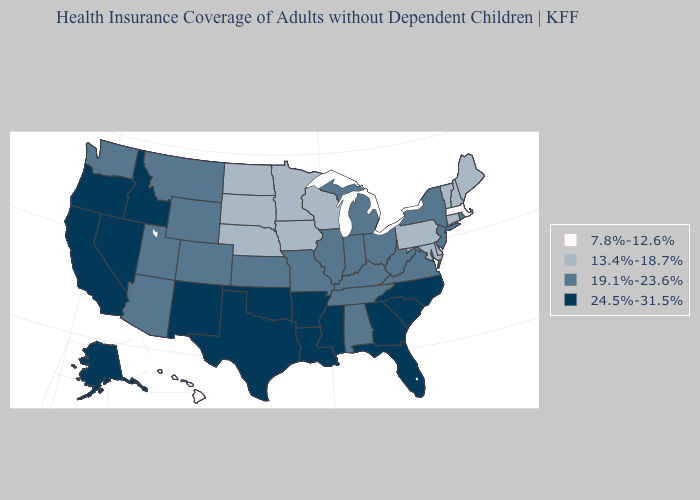What is the value of Hawaii?
Concise answer only. 7.8%-12.6%. Does the map have missing data?
Concise answer only. No. What is the value of Texas?
Be succinct. 24.5%-31.5%. Does Massachusetts have the lowest value in the USA?
Be succinct. Yes. Does Pennsylvania have the highest value in the Northeast?
Answer briefly. No. How many symbols are there in the legend?
Keep it brief. 4. Which states have the lowest value in the MidWest?
Concise answer only. Iowa, Minnesota, Nebraska, North Dakota, South Dakota, Wisconsin. Name the states that have a value in the range 24.5%-31.5%?
Answer briefly. Alaska, Arkansas, California, Florida, Georgia, Idaho, Louisiana, Mississippi, Nevada, New Mexico, North Carolina, Oklahoma, Oregon, South Carolina, Texas. Name the states that have a value in the range 24.5%-31.5%?
Quick response, please. Alaska, Arkansas, California, Florida, Georgia, Idaho, Louisiana, Mississippi, Nevada, New Mexico, North Carolina, Oklahoma, Oregon, South Carolina, Texas. Name the states that have a value in the range 13.4%-18.7%?
Be succinct. Connecticut, Delaware, Iowa, Maine, Maryland, Minnesota, Nebraska, New Hampshire, North Dakota, Pennsylvania, South Dakota, Vermont, Wisconsin. Does Oklahoma have the lowest value in the USA?
Keep it brief. No. What is the highest value in the MidWest ?
Short answer required. 19.1%-23.6%. Does the map have missing data?
Concise answer only. No. Name the states that have a value in the range 7.8%-12.6%?
Answer briefly. Hawaii, Massachusetts. Is the legend a continuous bar?
Short answer required. No. 